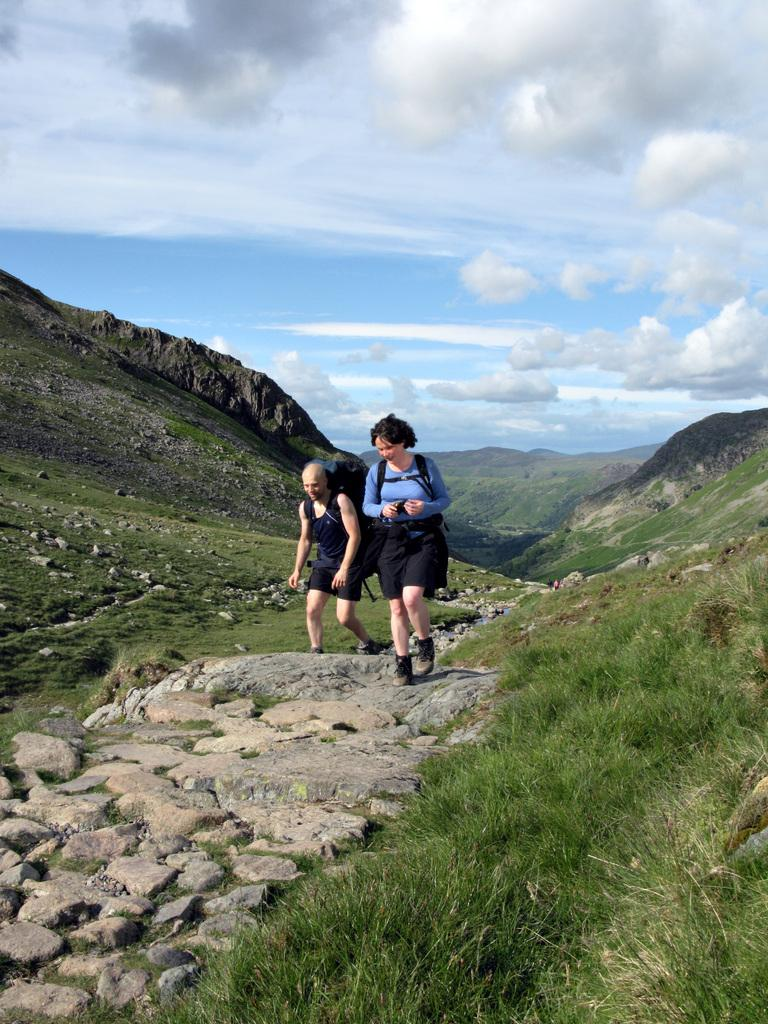How many people are in the image? There are two people in the image. Where are the people located in the image? The people are on rocks in the image. What type of landscape can be seen in the background? There are mountains visible in the image. What type of vegetation is present in the image? There is grass in the image. How would you describe the weather based on the sky in the image? The sky is cloudy in the image, suggesting overcast or potentially rainy weather. What type of sail can be seen on the sea in the image? There is no sea or sail present in the image; it features people on rocks with mountains and grass in the background. 